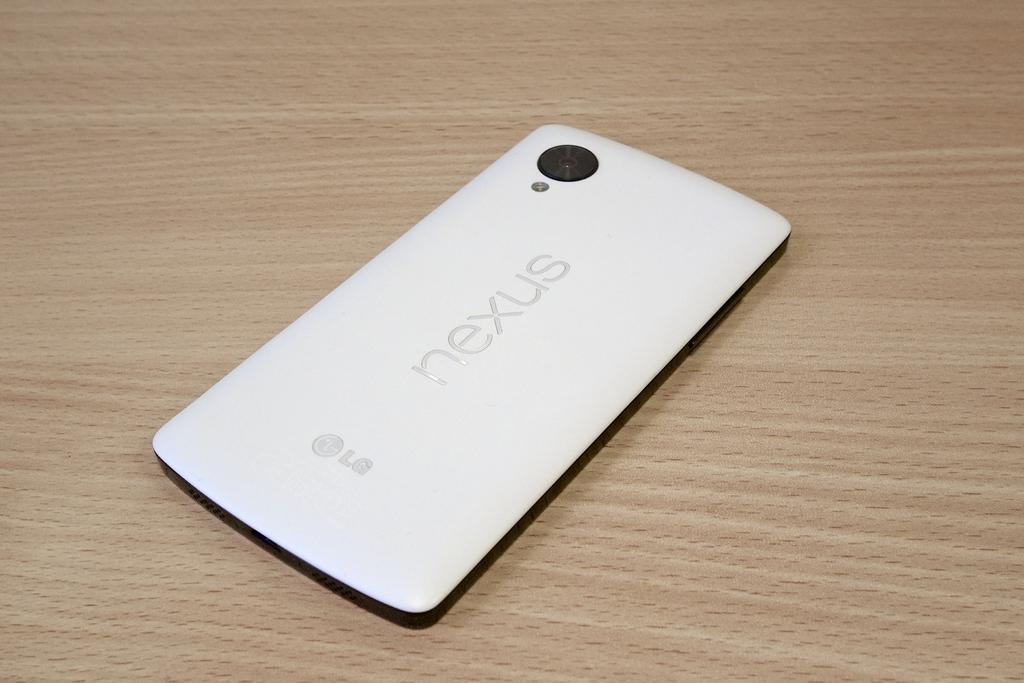<image>
Share a concise interpretation of the image provided. A white nexus phone that is made by LG 